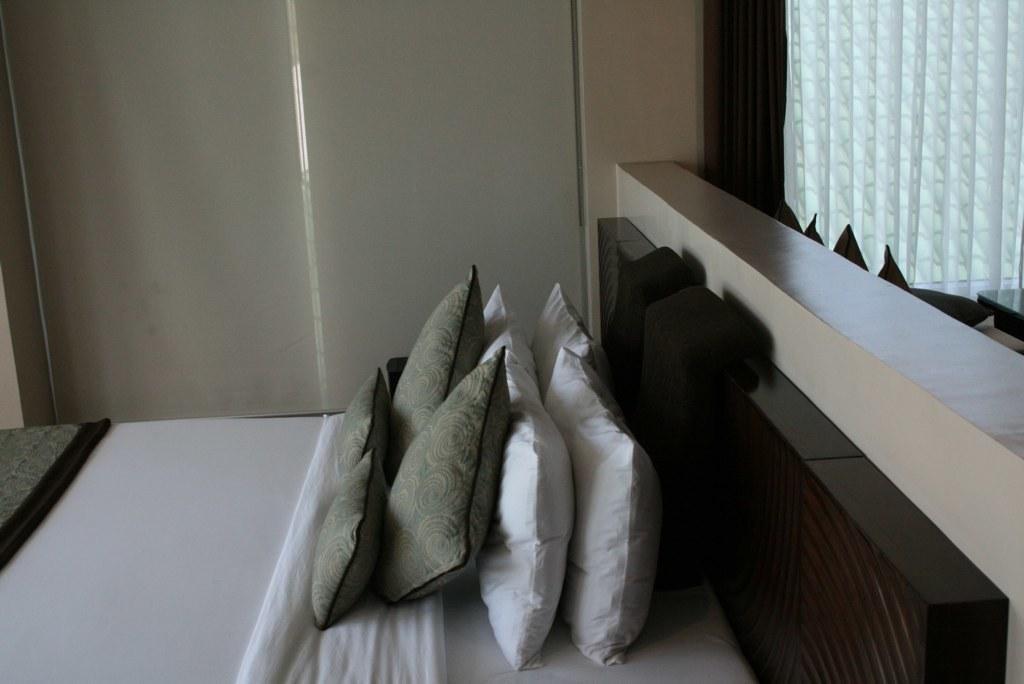Can you describe this image briefly? This is the picture of some pillows on the bed which are in white and grey color. 